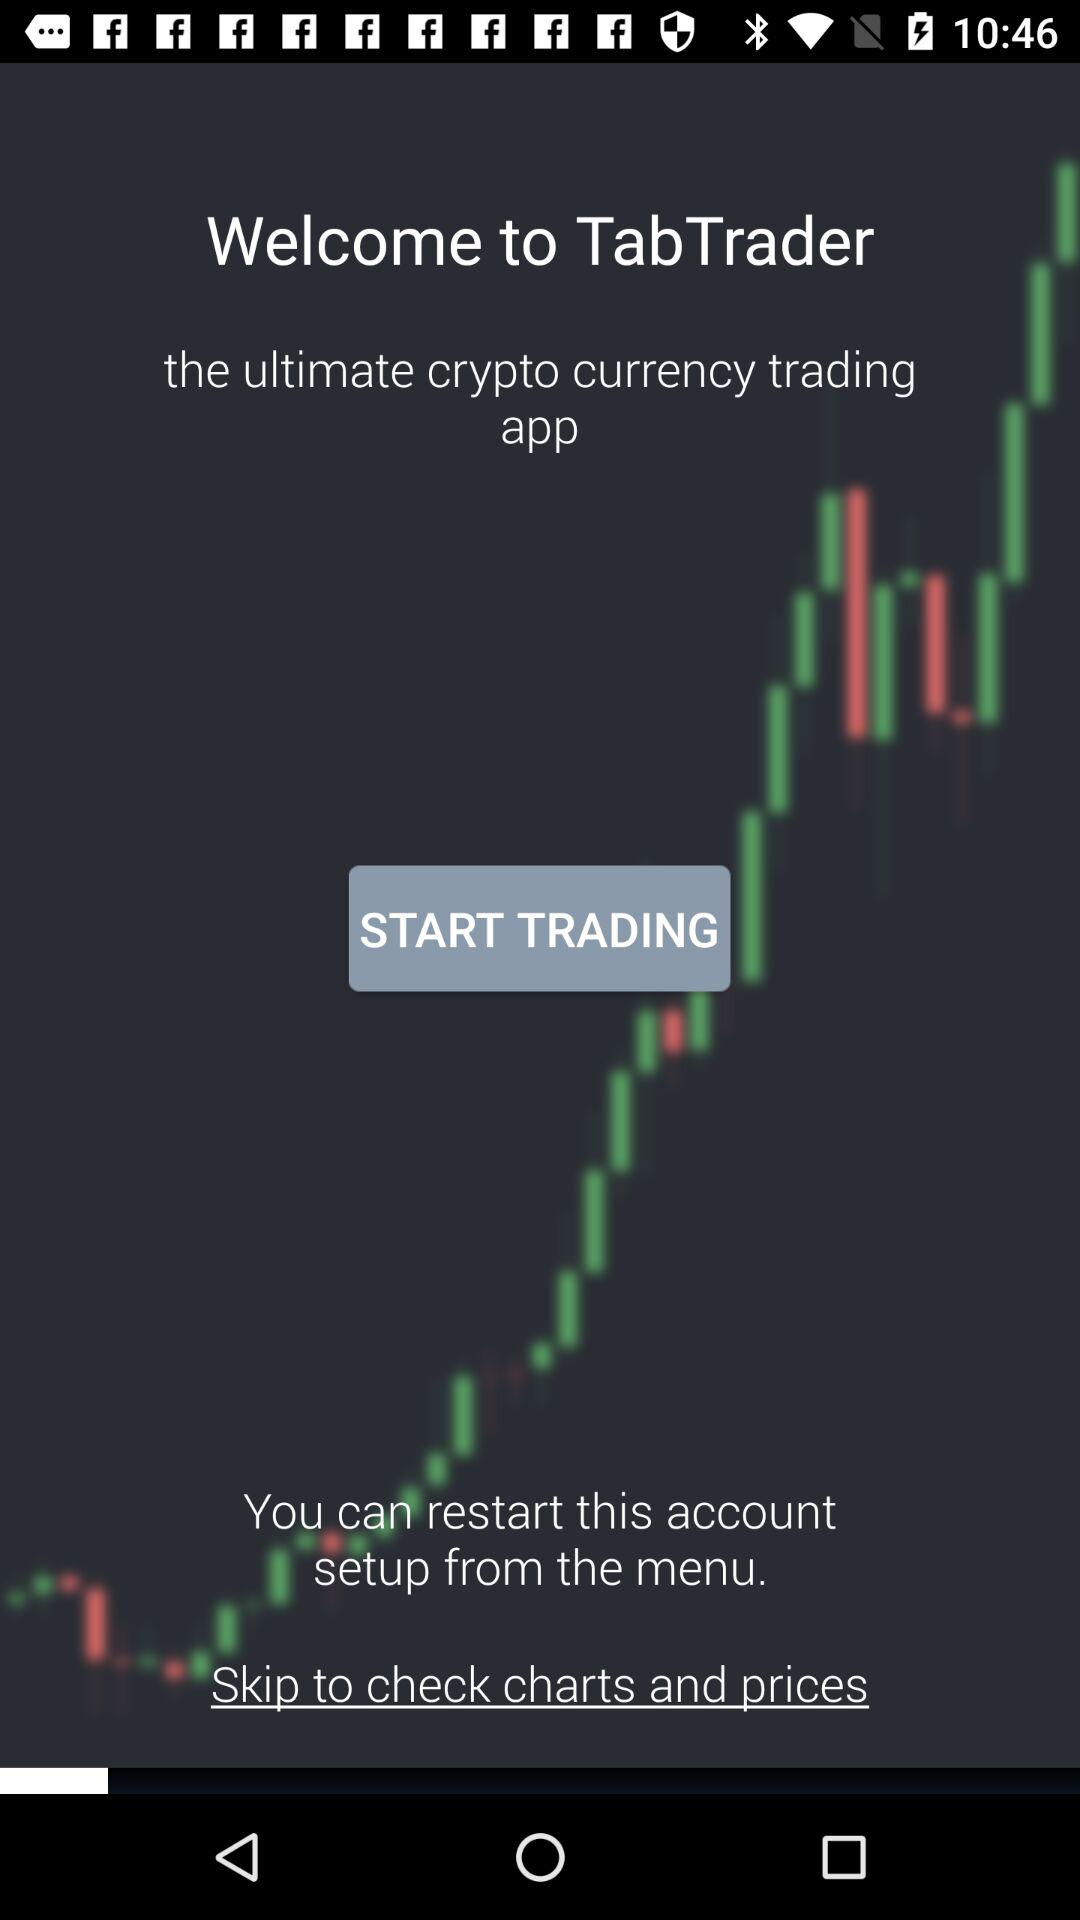What is the application name? The application name is "TabTrader". 